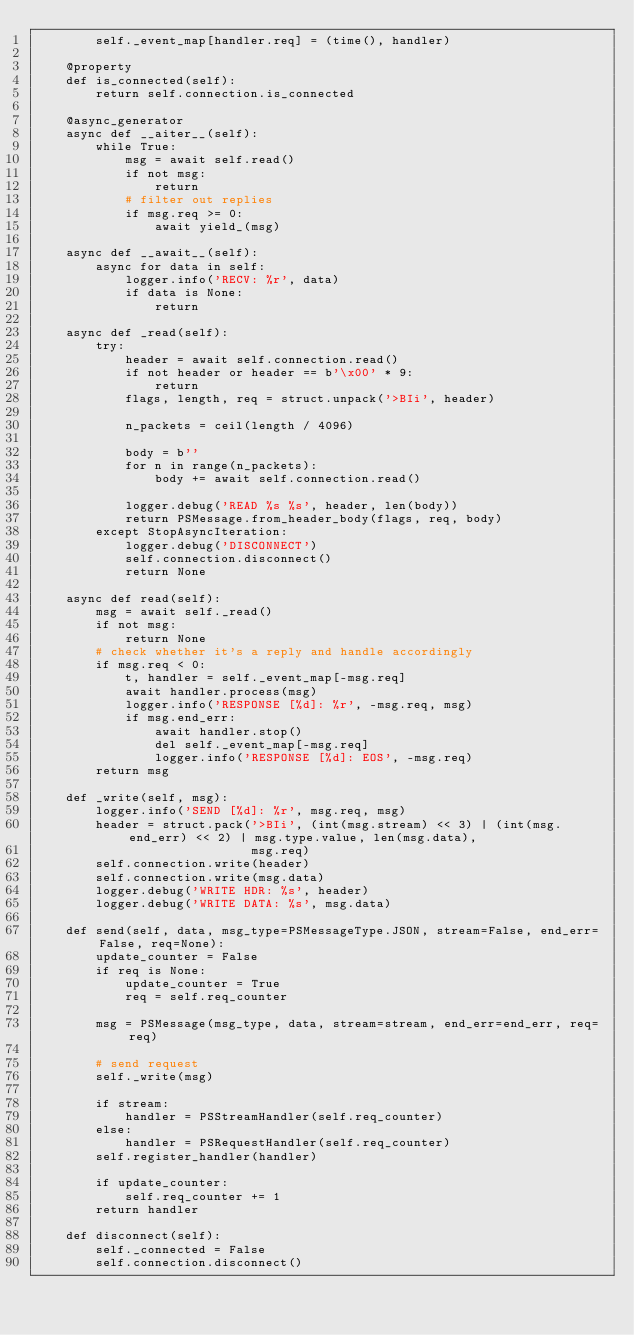<code> <loc_0><loc_0><loc_500><loc_500><_Python_>        self._event_map[handler.req] = (time(), handler)

    @property
    def is_connected(self):
        return self.connection.is_connected

    @async_generator
    async def __aiter__(self):
        while True:
            msg = await self.read()
            if not msg:
                return
            # filter out replies
            if msg.req >= 0:
                await yield_(msg)

    async def __await__(self):
        async for data in self:
            logger.info('RECV: %r', data)
            if data is None:
                return

    async def _read(self):
        try:
            header = await self.connection.read()
            if not header or header == b'\x00' * 9:
                return
            flags, length, req = struct.unpack('>BIi', header)

            n_packets = ceil(length / 4096)

            body = b''
            for n in range(n_packets):
                body += await self.connection.read()

            logger.debug('READ %s %s', header, len(body))
            return PSMessage.from_header_body(flags, req, body)
        except StopAsyncIteration:
            logger.debug('DISCONNECT')
            self.connection.disconnect()
            return None

    async def read(self):
        msg = await self._read()
        if not msg:
            return None
        # check whether it's a reply and handle accordingly
        if msg.req < 0:
            t, handler = self._event_map[-msg.req]
            await handler.process(msg)
            logger.info('RESPONSE [%d]: %r', -msg.req, msg)
            if msg.end_err:
                await handler.stop()
                del self._event_map[-msg.req]
                logger.info('RESPONSE [%d]: EOS', -msg.req)
        return msg

    def _write(self, msg):
        logger.info('SEND [%d]: %r', msg.req, msg)
        header = struct.pack('>BIi', (int(msg.stream) << 3) | (int(msg.end_err) << 2) | msg.type.value, len(msg.data),
                             msg.req)
        self.connection.write(header)
        self.connection.write(msg.data)
        logger.debug('WRITE HDR: %s', header)
        logger.debug('WRITE DATA: %s', msg.data)

    def send(self, data, msg_type=PSMessageType.JSON, stream=False, end_err=False, req=None):
        update_counter = False
        if req is None:
            update_counter = True
            req = self.req_counter

        msg = PSMessage(msg_type, data, stream=stream, end_err=end_err, req=req)

        # send request
        self._write(msg)

        if stream:
            handler = PSStreamHandler(self.req_counter)
        else:
            handler = PSRequestHandler(self.req_counter)
        self.register_handler(handler)

        if update_counter:
            self.req_counter += 1
        return handler

    def disconnect(self):
        self._connected = False
        self.connection.disconnect()
</code> 